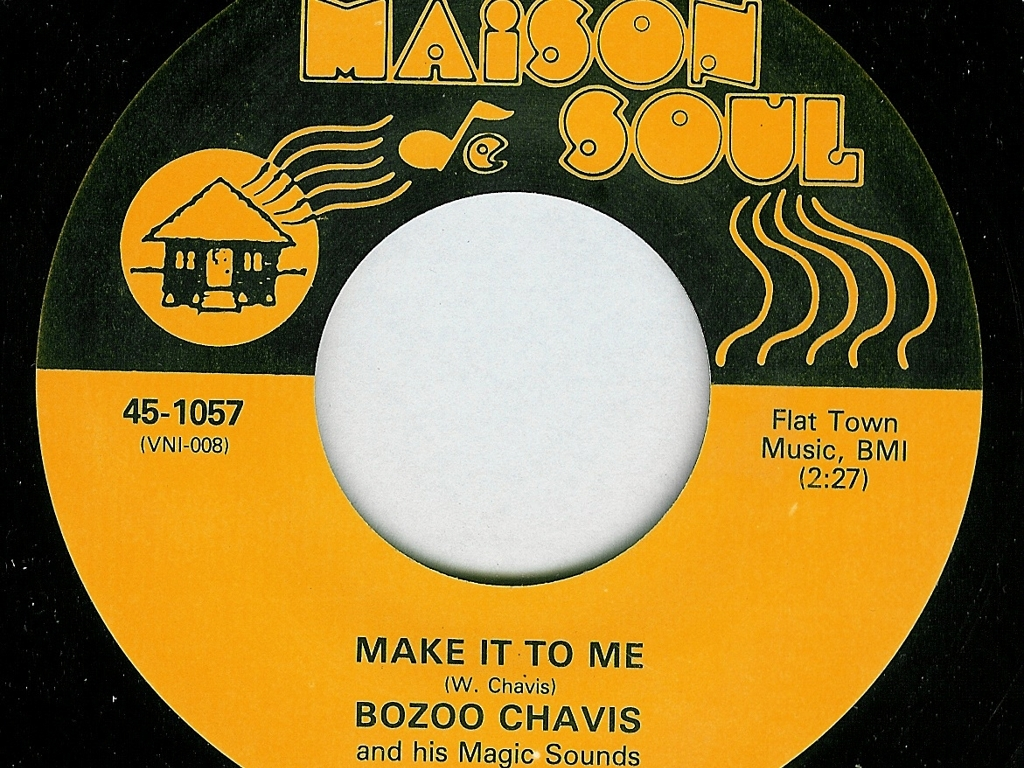What can you infer about the music on this record based on the label design? The label design suggests a focus on soul or rhythm and blues music, as indicated by the name 'Maison de Soul' and the stylized music notes. The artist's name, 'Boozoo Chavis,' hints at a possible Southern or Louisiana influence, perhaps suggesting the record may contain elements of zydeco or Southern soul music. The track title 'MAKE IT TO ME' combined with the lively design implies an upbeat and energetic song, likely to get listeners moving and grooving. 